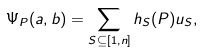<formula> <loc_0><loc_0><loc_500><loc_500>\Psi _ { P } ( a , b ) = \sum _ { S \subseteq [ 1 , n ] } h _ { S } ( P ) u _ { S } ,</formula> 